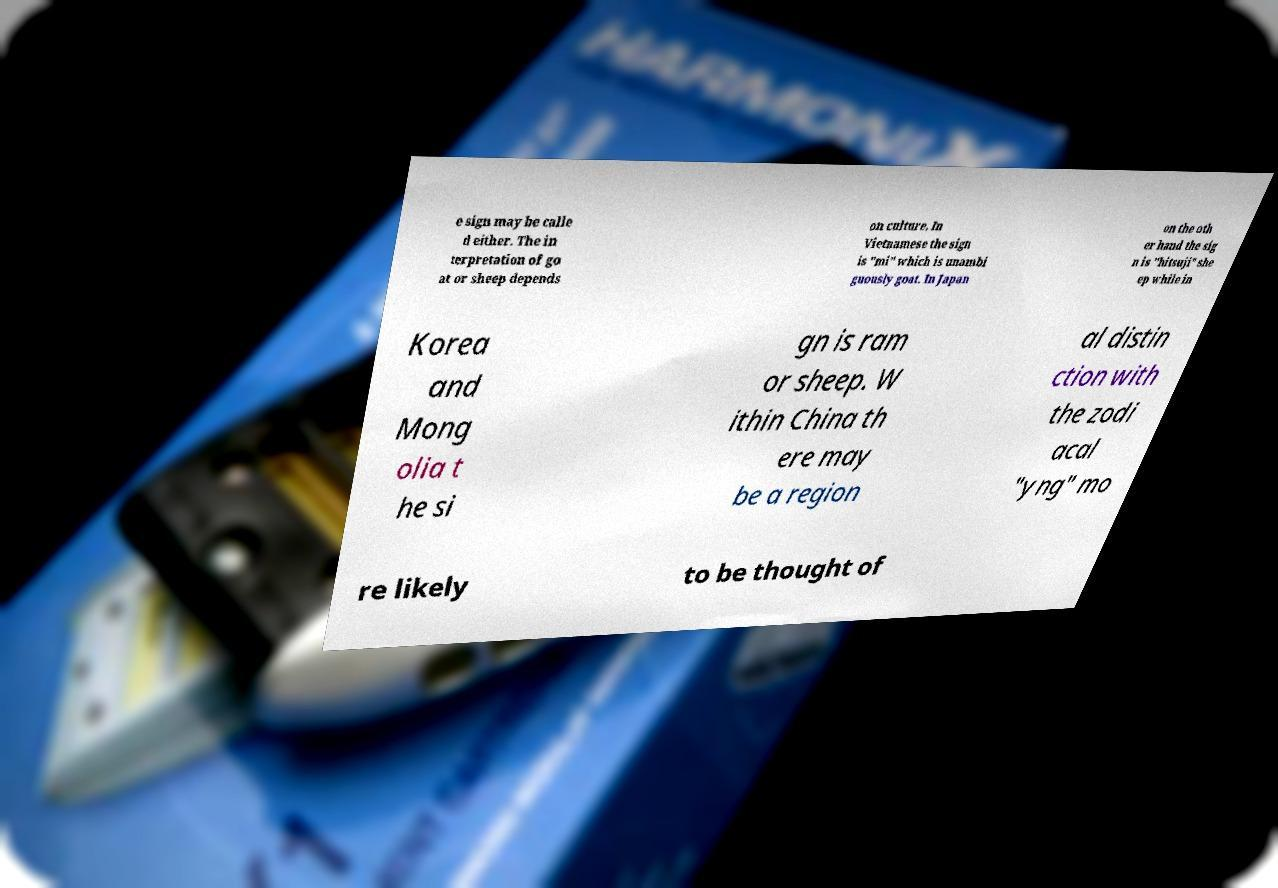Can you accurately transcribe the text from the provided image for me? e sign may be calle d either. The in terpretation of go at or sheep depends on culture. In Vietnamese the sign is "mi" which is unambi guously goat. In Japan on the oth er hand the sig n is "hitsuji" she ep while in Korea and Mong olia t he si gn is ram or sheep. W ithin China th ere may be a region al distin ction with the zodi acal "yng" mo re likely to be thought of 